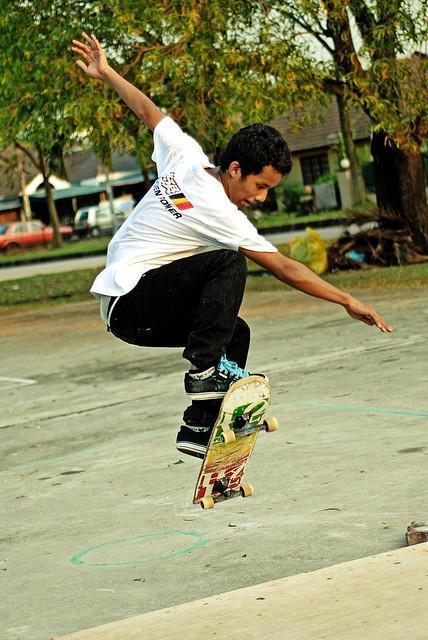How many wheels are on this skateboard?
Give a very brief answer. 4. 